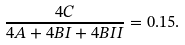Convert formula to latex. <formula><loc_0><loc_0><loc_500><loc_500>\frac { 4 C } { 4 A + 4 B I + 4 B I I } = 0 . 1 5 .</formula> 